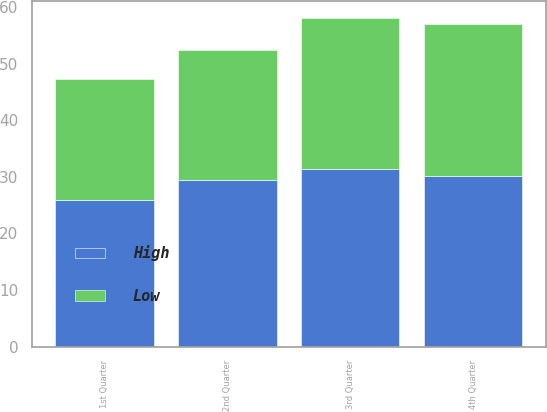Convert chart. <chart><loc_0><loc_0><loc_500><loc_500><stacked_bar_chart><ecel><fcel>1st Quarter<fcel>2nd Quarter<fcel>3rd Quarter<fcel>4th Quarter<nl><fcel>High<fcel>25.86<fcel>29.41<fcel>31.4<fcel>30.13<nl><fcel>Low<fcel>21.56<fcel>23.1<fcel>26.79<fcel>26.89<nl></chart> 